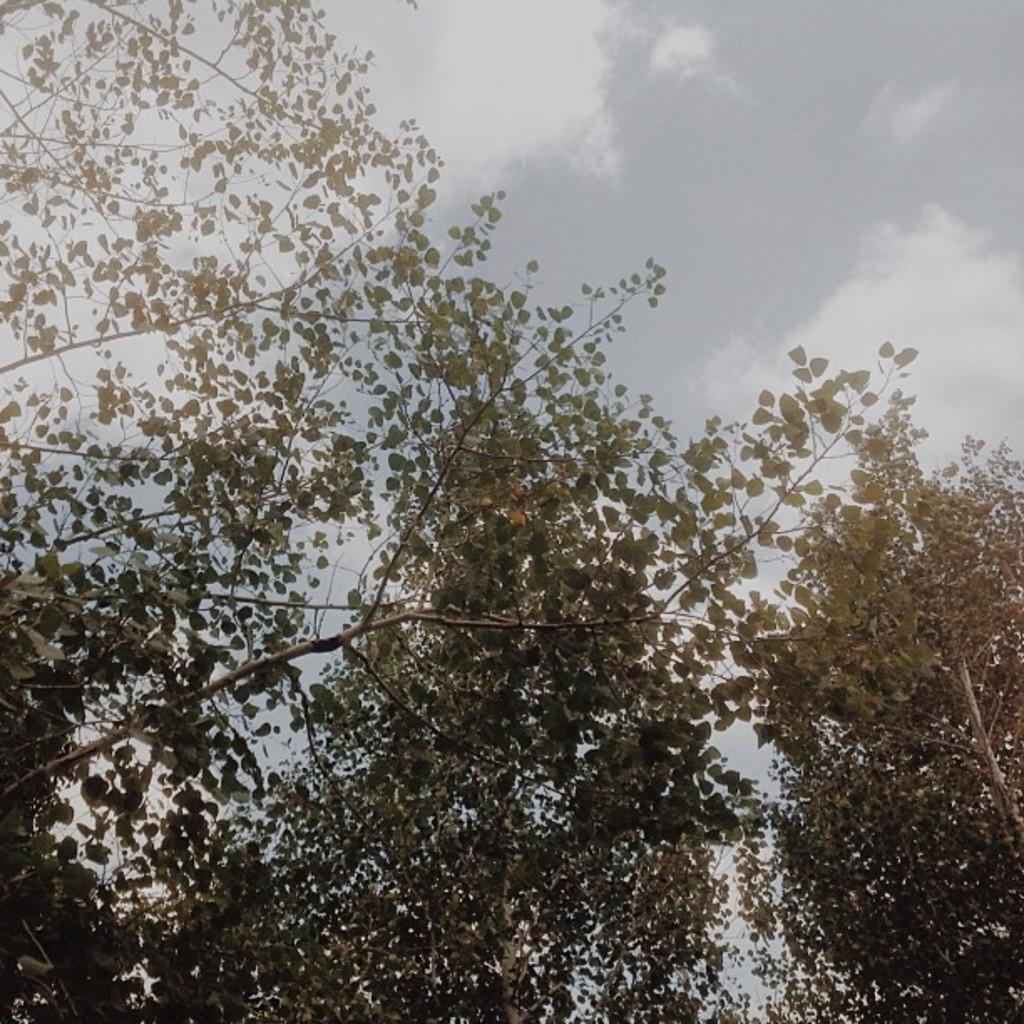What type of vegetation is present on the left side of the image? There are trees with green leaves on the left side of the image. Is there a similar type of vegetation on the right side of the image? Yes, there is a tree with green leaves on the right side of the image. What can be seen in the sky in the background of the image? There are clouds in the sky in the background of the image. What type of news can be heard coming from the window in the image? There is no window present in the image, and therefore no news can be heard coming from it. 